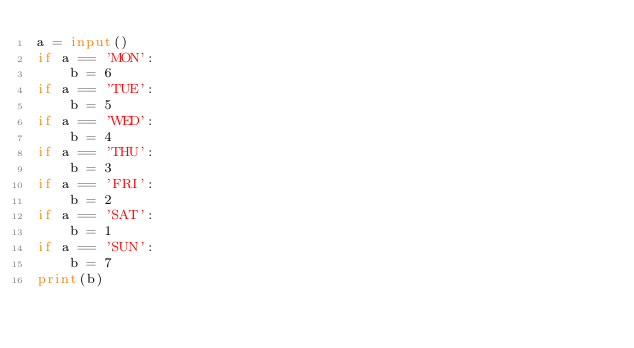Convert code to text. <code><loc_0><loc_0><loc_500><loc_500><_Python_>a = input()
if a == 'MON':
    b = 6
if a == 'TUE':
    b = 5
if a == 'WED':
    b = 4
if a == 'THU':
    b = 3
if a == 'FRI':
    b = 2
if a == 'SAT':
    b = 1
if a == 'SUN':
    b = 7
print(b)
</code> 